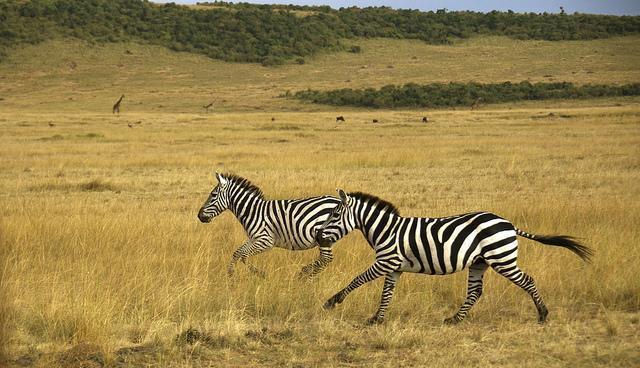How many animals are depicted?
Give a very brief answer. 2. How many zebras are in the photo?
Give a very brief answer. 2. 